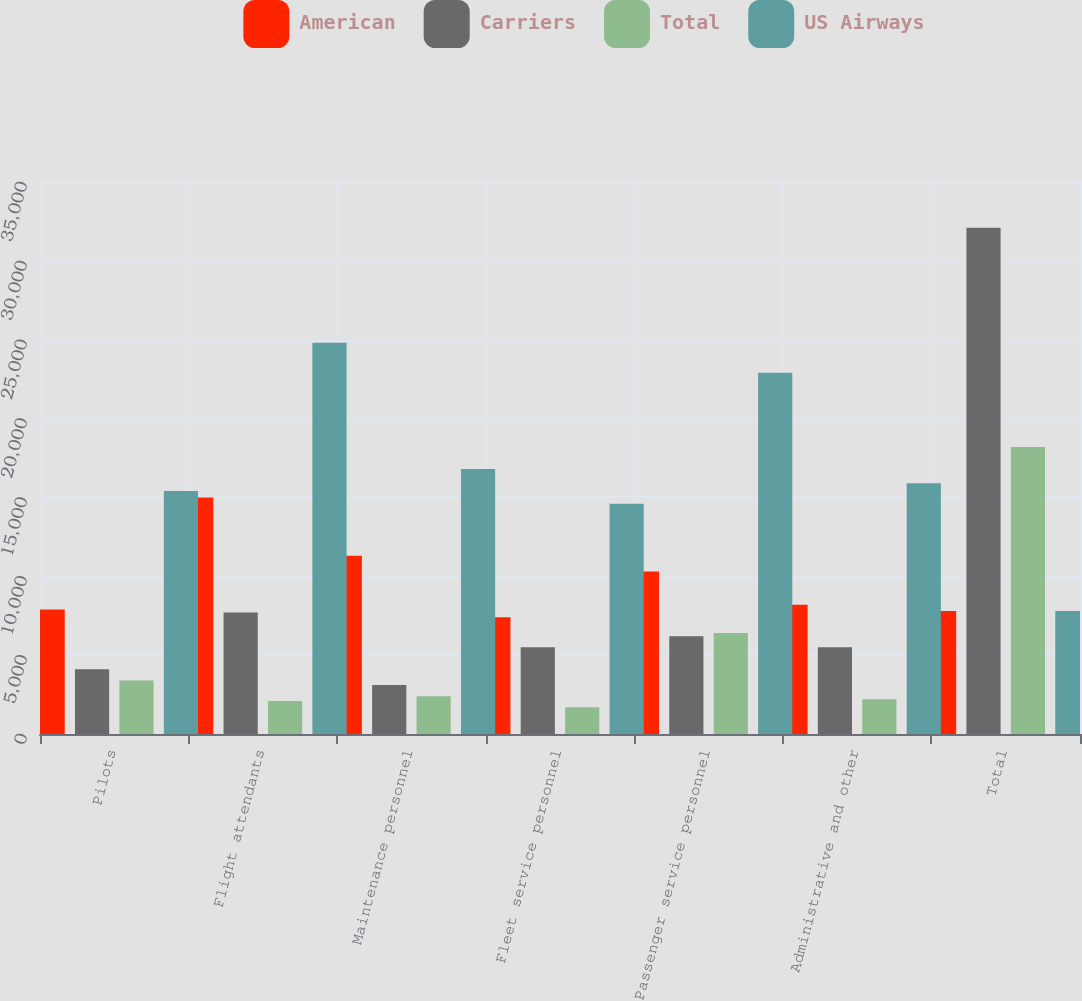<chart> <loc_0><loc_0><loc_500><loc_500><stacked_bar_chart><ecel><fcel>Pilots<fcel>Flight attendants<fcel>Maintenance personnel<fcel>Fleet service personnel<fcel>Passenger service personnel<fcel>Administrative and other<fcel>Total<nl><fcel>American<fcel>7900<fcel>15000<fcel>11300<fcel>7400<fcel>10300<fcel>8200<fcel>7800<nl><fcel>Carriers<fcel>4100<fcel>7700<fcel>3100<fcel>5500<fcel>6200<fcel>5500<fcel>32100<nl><fcel>Total<fcel>3400<fcel>2100<fcel>2400<fcel>1700<fcel>6400<fcel>2200<fcel>18200<nl><fcel>US Airways<fcel>15400<fcel>24800<fcel>16800<fcel>14600<fcel>22900<fcel>15900<fcel>7800<nl></chart> 